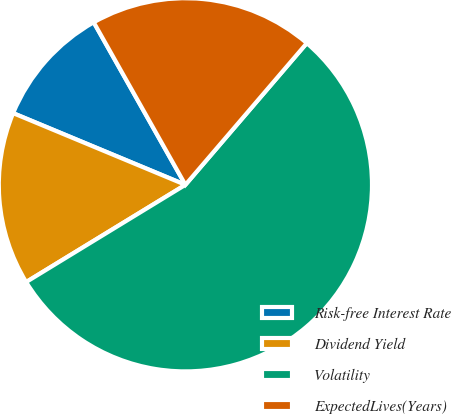<chart> <loc_0><loc_0><loc_500><loc_500><pie_chart><fcel>Risk-free Interest Rate<fcel>Dividend Yield<fcel>Volatility<fcel>ExpectedLives(Years)<nl><fcel>10.55%<fcel>15.0%<fcel>55.0%<fcel>19.45%<nl></chart> 